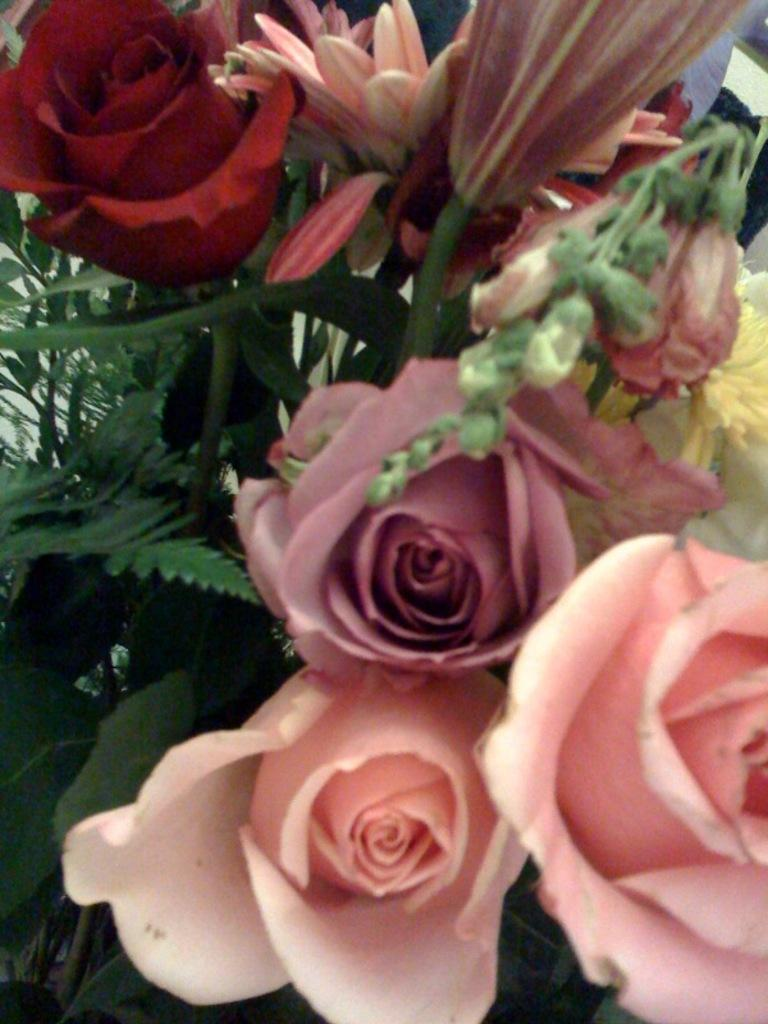What is the main subject of the image? The main subject of the image is a bouquet with different flowers. Can you describe the flowers in the bouquet? Unfortunately, the facts provided do not give specific details about the flowers in the bouquet. Is there anything else present in the image besides the bouquet? The facts provided do not mention any other objects or subjects in the image. How many deer can be seen grazing in the background of the image? There are no deer present in the image; it features a bouquet with different flowers. What type of drink is being served in the image? There is no drink present in the image; it features a bouquet with different flowers. 